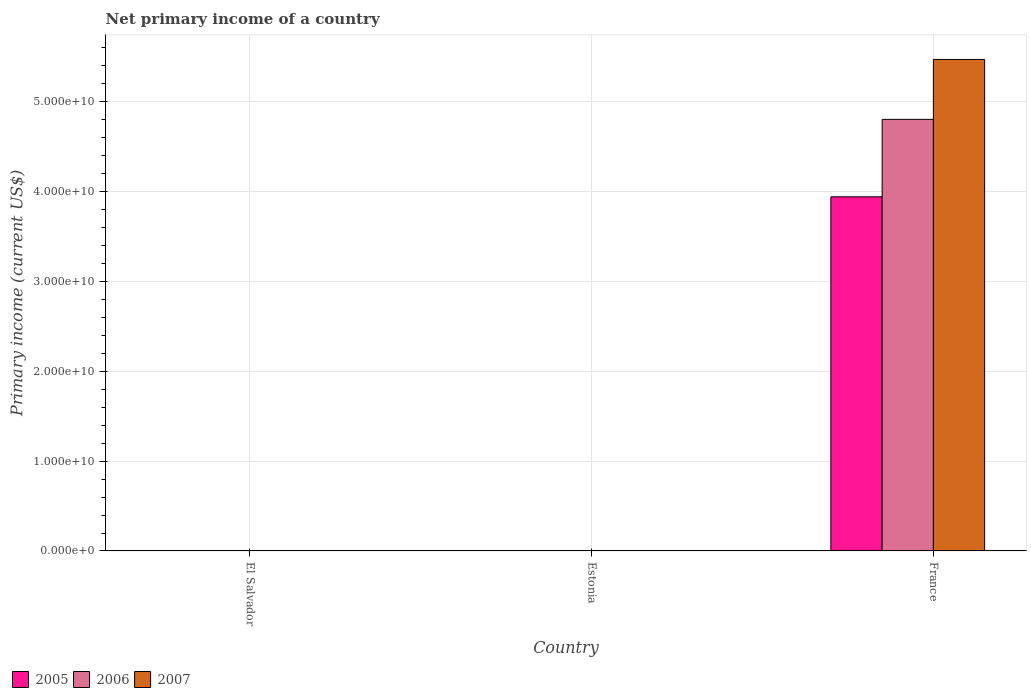How many different coloured bars are there?
Your response must be concise. 3. Are the number of bars on each tick of the X-axis equal?
Provide a short and direct response. No. How many bars are there on the 1st tick from the left?
Provide a short and direct response. 0. How many bars are there on the 1st tick from the right?
Give a very brief answer. 3. What is the label of the 2nd group of bars from the left?
Offer a very short reply. Estonia. What is the primary income in 2005 in Estonia?
Your answer should be compact. 0. Across all countries, what is the maximum primary income in 2006?
Your response must be concise. 4.80e+1. Across all countries, what is the minimum primary income in 2006?
Offer a terse response. 0. In which country was the primary income in 2005 maximum?
Ensure brevity in your answer.  France. What is the total primary income in 2006 in the graph?
Give a very brief answer. 4.80e+1. What is the difference between the primary income in 2005 in Estonia and the primary income in 2006 in El Salvador?
Keep it short and to the point. 0. What is the average primary income in 2006 per country?
Keep it short and to the point. 1.60e+1. What is the difference between the primary income of/in 2006 and primary income of/in 2005 in France?
Ensure brevity in your answer.  8.62e+09. In how many countries, is the primary income in 2007 greater than 8000000000 US$?
Ensure brevity in your answer.  1. What is the difference between the highest and the lowest primary income in 2007?
Keep it short and to the point. 5.47e+1. In how many countries, is the primary income in 2007 greater than the average primary income in 2007 taken over all countries?
Make the answer very short. 1. Is it the case that in every country, the sum of the primary income in 2006 and primary income in 2005 is greater than the primary income in 2007?
Your answer should be compact. No. How many bars are there?
Ensure brevity in your answer.  3. How many countries are there in the graph?
Provide a short and direct response. 3. What is the difference between two consecutive major ticks on the Y-axis?
Your answer should be very brief. 1.00e+1. Does the graph contain any zero values?
Your answer should be compact. Yes. How are the legend labels stacked?
Offer a very short reply. Horizontal. What is the title of the graph?
Your response must be concise. Net primary income of a country. What is the label or title of the Y-axis?
Offer a terse response. Primary income (current US$). What is the Primary income (current US$) in 2006 in El Salvador?
Make the answer very short. 0. What is the Primary income (current US$) in 2006 in Estonia?
Make the answer very short. 0. What is the Primary income (current US$) of 2005 in France?
Offer a very short reply. 3.94e+1. What is the Primary income (current US$) in 2006 in France?
Make the answer very short. 4.80e+1. What is the Primary income (current US$) of 2007 in France?
Give a very brief answer. 5.47e+1. Across all countries, what is the maximum Primary income (current US$) in 2005?
Provide a succinct answer. 3.94e+1. Across all countries, what is the maximum Primary income (current US$) of 2006?
Offer a very short reply. 4.80e+1. Across all countries, what is the maximum Primary income (current US$) of 2007?
Your response must be concise. 5.47e+1. Across all countries, what is the minimum Primary income (current US$) of 2007?
Offer a terse response. 0. What is the total Primary income (current US$) of 2005 in the graph?
Make the answer very short. 3.94e+1. What is the total Primary income (current US$) in 2006 in the graph?
Your answer should be very brief. 4.80e+1. What is the total Primary income (current US$) in 2007 in the graph?
Provide a short and direct response. 5.47e+1. What is the average Primary income (current US$) in 2005 per country?
Offer a very short reply. 1.31e+1. What is the average Primary income (current US$) of 2006 per country?
Your response must be concise. 1.60e+1. What is the average Primary income (current US$) of 2007 per country?
Offer a terse response. 1.82e+1. What is the difference between the Primary income (current US$) in 2005 and Primary income (current US$) in 2006 in France?
Offer a terse response. -8.62e+09. What is the difference between the Primary income (current US$) in 2005 and Primary income (current US$) in 2007 in France?
Offer a very short reply. -1.53e+1. What is the difference between the Primary income (current US$) of 2006 and Primary income (current US$) of 2007 in France?
Make the answer very short. -6.67e+09. What is the difference between the highest and the lowest Primary income (current US$) of 2005?
Ensure brevity in your answer.  3.94e+1. What is the difference between the highest and the lowest Primary income (current US$) of 2006?
Make the answer very short. 4.80e+1. What is the difference between the highest and the lowest Primary income (current US$) of 2007?
Your response must be concise. 5.47e+1. 